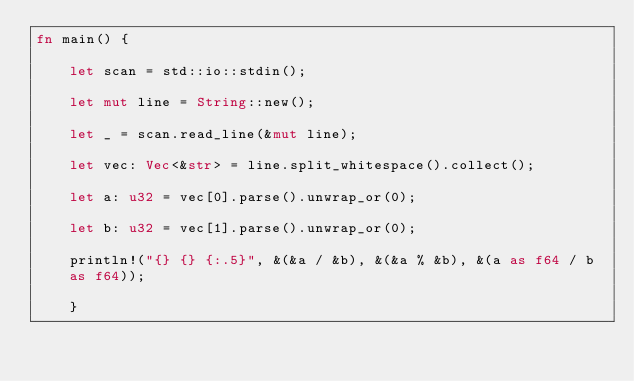Convert code to text. <code><loc_0><loc_0><loc_500><loc_500><_Rust_>fn main() {                                                                                                                                                                                                                                      let scan = std::io::stdin();                                                                                                                                                                                                                                                                                                                                                                                                                                                              let mut line = String::new();                                                                                                                                                                                                                                                                                                                                                                                                                                                             let _ = scan.read_line(&mut line);                                                                                                                                                                                                           let vec: Vec<&str> = line.split_whitespace().collect();                                                                                                                                                                                                                                                                                                                                                                                                                                   let a: u32 = vec[0].parse().unwrap_or(0);                                                                                                                                                                                                    let b: u32 = vec[1].parse().unwrap_or(0);                                                                                                                                                                                                                                                                                                                                                                                                                                                 println!("{} {} {:.5}", &(&a / &b), &(&a % &b), &(a as f64 / b as f64));                                                                                                                                                                 }
</code> 